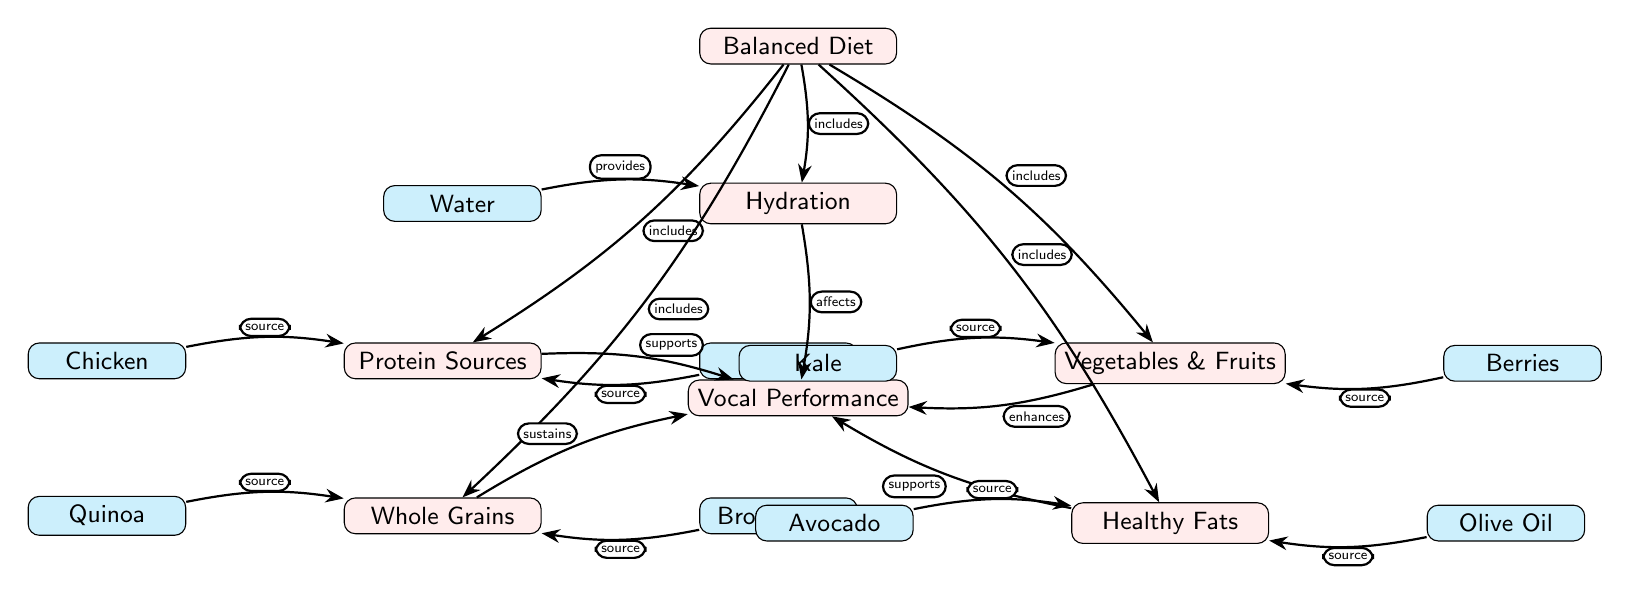What are the five main categories depicted in the diagram? The diagram lists five main categories: Balanced Diet, Hydration, Protein Sources, Vegetables & Fruits, Whole Grains, and Healthy Fats.
Answer: Balanced Diet, Hydration, Protein Sources, Vegetables & Fruits, Whole Grains, Healthy Fats How many items are sources for Protein Sources? There are two items depicted under Protein Sources: Chicken and Tofu, which are shown as sources directly connected to the Protein Sources node.
Answer: 2 What nutrient source is identified for Healthy Fats? The diagram identifies Avocado and Olive Oil as sources for Healthy Fats, which are shown as items connected to the Healthy Fats node.
Answer: Avocado, Olive Oil Which category directly affects Vocal Performance? The Hydration category is indicated in the diagram to have a direct relationship with Vocal Performance, as it shows an "affects" connection.
Answer: Hydration How does Hydration contribute to Vocal Performance? Hydration is illustrated as a category that "affects" Vocal Performance in the diagram, highlighting its importance in maintaining vocal health.
Answer: Affects Which item is connected to Vegetables & Fruits? Kale and Berries are the items connected to Vegetables & Fruits in the diagram, specifically indicating their role in vocal performance enhancement.
Answer: Kale, Berries What role does Whole Grains play in Vocal Performance? The diagram shows that Whole Grains "sustain" Vocal Performance, indicating their supportive role in maintaining vocal health.
Answer: Sustains Which nodes represent sources of nutrients in the diagram? The sources of nutrients are: Chicken, Tofu, Kale, Berries, Quinoa, Brown Rice, Avocado, and Olive Oil, which are all connected to their respective nutrient categories.
Answer: Chicken, Tofu, Kale, Berries, Quinoa, Brown Rice, Avocado, Olive Oil What type of relationship exists between Protein Sources and Vocal Performance? The connection between Protein Sources and Vocal Performance is labeled as "supports" in the diagram, denoting how protein contributes to vocal health.
Answer: Supports 